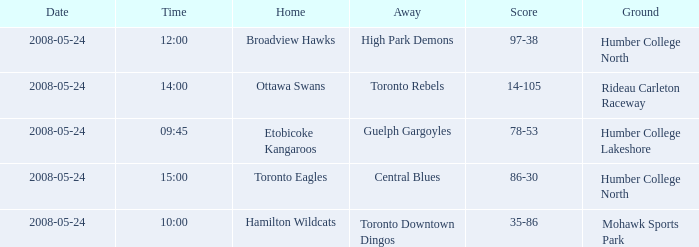Who was the home team of the game at the time of 15:00? Toronto Eagles. 